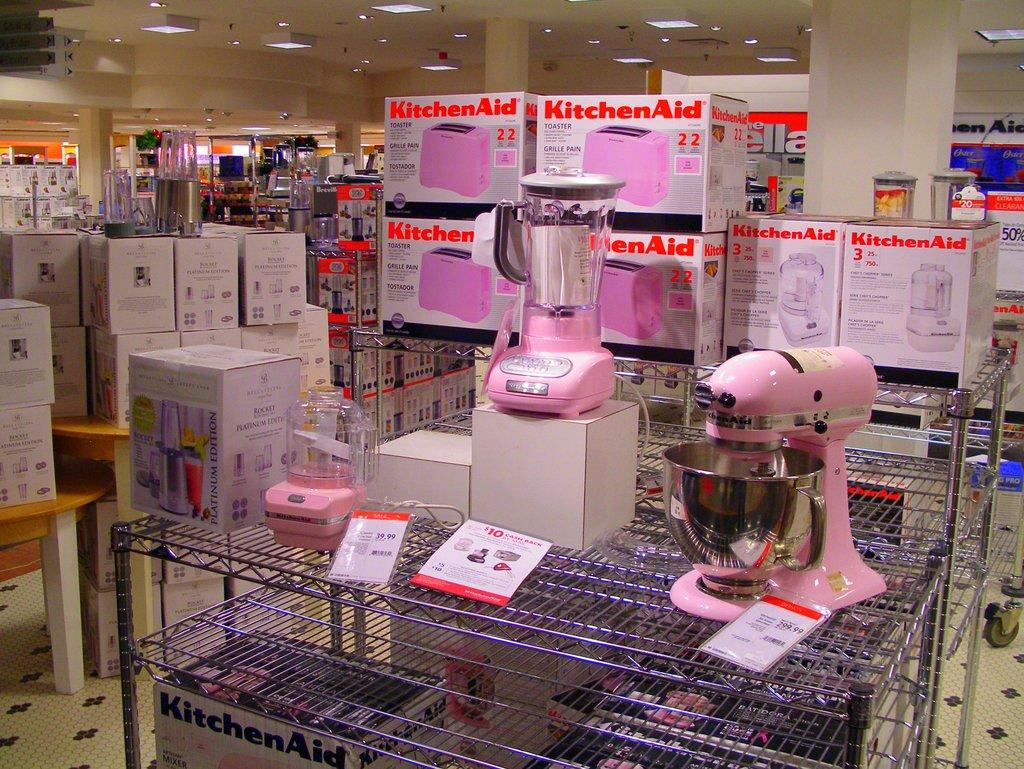<image>
Describe the image concisely. Some pink kitchen appliances in boxes reading kitchen aid 